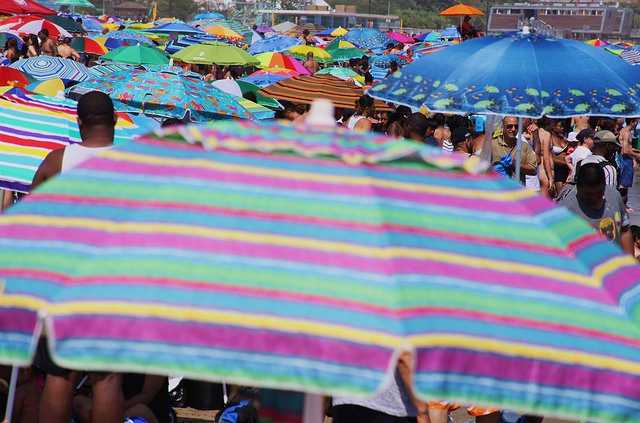Describe the objects in this image and their specific colors. I can see umbrella in brown, lightblue, darkgray, and aquamarine tones, people in brown, black, maroon, and gray tones, umbrella in brown, blue, and gray tones, people in brown, maroon, black, and lavender tones, and umbrella in brown, lightblue, and teal tones in this image. 